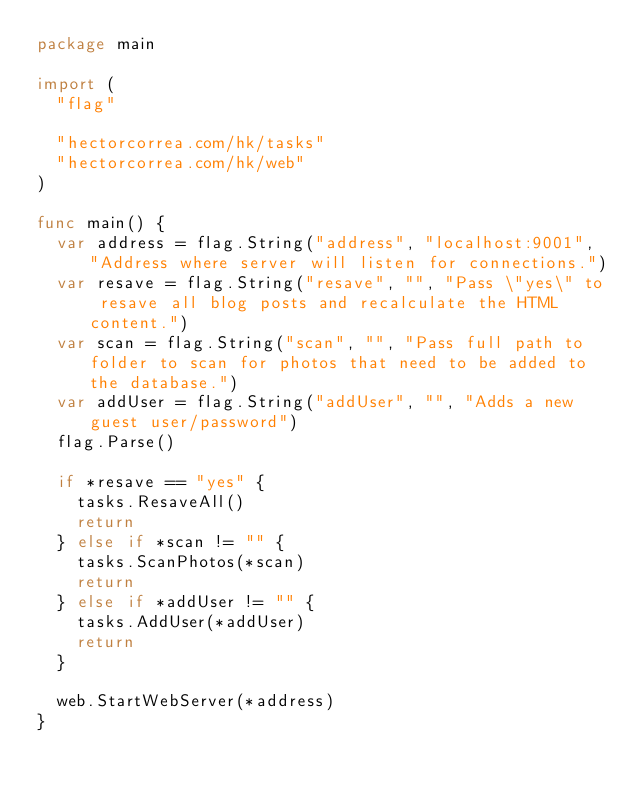Convert code to text. <code><loc_0><loc_0><loc_500><loc_500><_Go_>package main

import (
	"flag"

	"hectorcorrea.com/hk/tasks"
	"hectorcorrea.com/hk/web"
)

func main() {
	var address = flag.String("address", "localhost:9001", "Address where server will listen for connections.")
	var resave = flag.String("resave", "", "Pass \"yes\" to resave all blog posts and recalculate the HTML content.")
	var scan = flag.String("scan", "", "Pass full path to folder to scan for photos that need to be added to the database.")
	var addUser = flag.String("addUser", "", "Adds a new guest user/password")
	flag.Parse()

	if *resave == "yes" {
		tasks.ResaveAll()
		return
	} else if *scan != "" {
		tasks.ScanPhotos(*scan)
		return
	} else if *addUser != "" {
		tasks.AddUser(*addUser)
		return
	}

	web.StartWebServer(*address)
}
</code> 